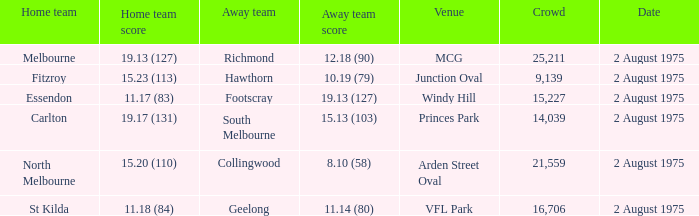When did the game at Arden Street Oval occur? 2 August 1975. 